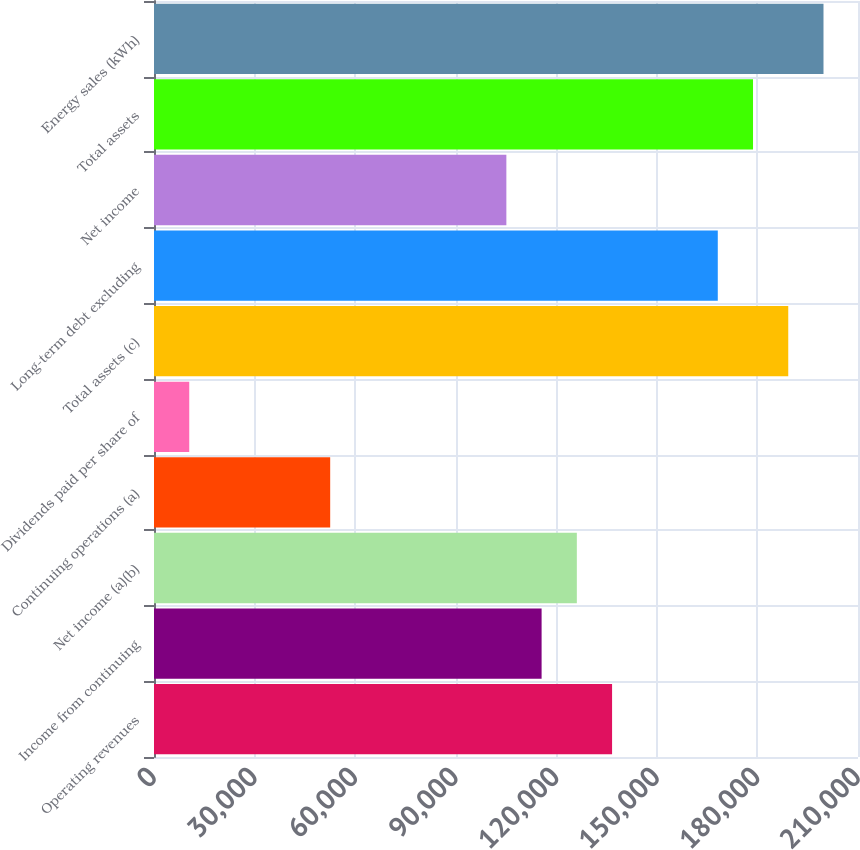Convert chart to OTSL. <chart><loc_0><loc_0><loc_500><loc_500><bar_chart><fcel>Operating revenues<fcel>Income from continuing<fcel>Net income (a)(b)<fcel>Continuing operations (a)<fcel>Dividends paid per share of<fcel>Total assets (c)<fcel>Long-term debt excluding<fcel>Net income<fcel>Total assets<fcel>Energy sales (kWh)<nl><fcel>136641<fcel>115620<fcel>126131<fcel>52554.8<fcel>10511.5<fcel>189196<fcel>168174<fcel>105109<fcel>178685<fcel>199706<nl></chart> 